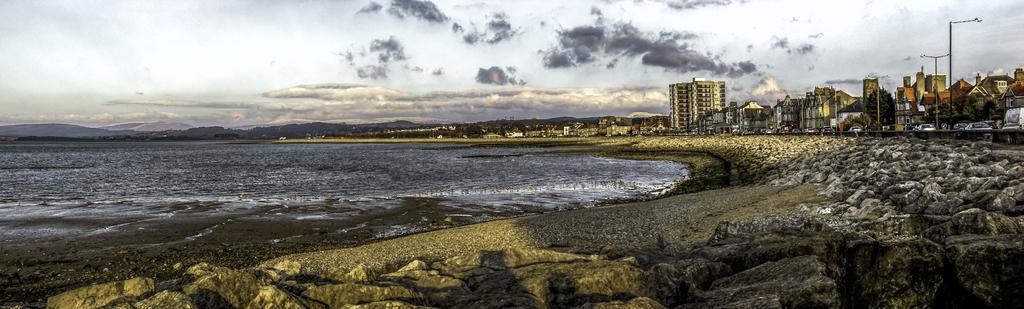Can you describe this image briefly? On the right side of the image there are buildings and poles. On the left side of the image there is a river. In the background there are mountains and a sky. 